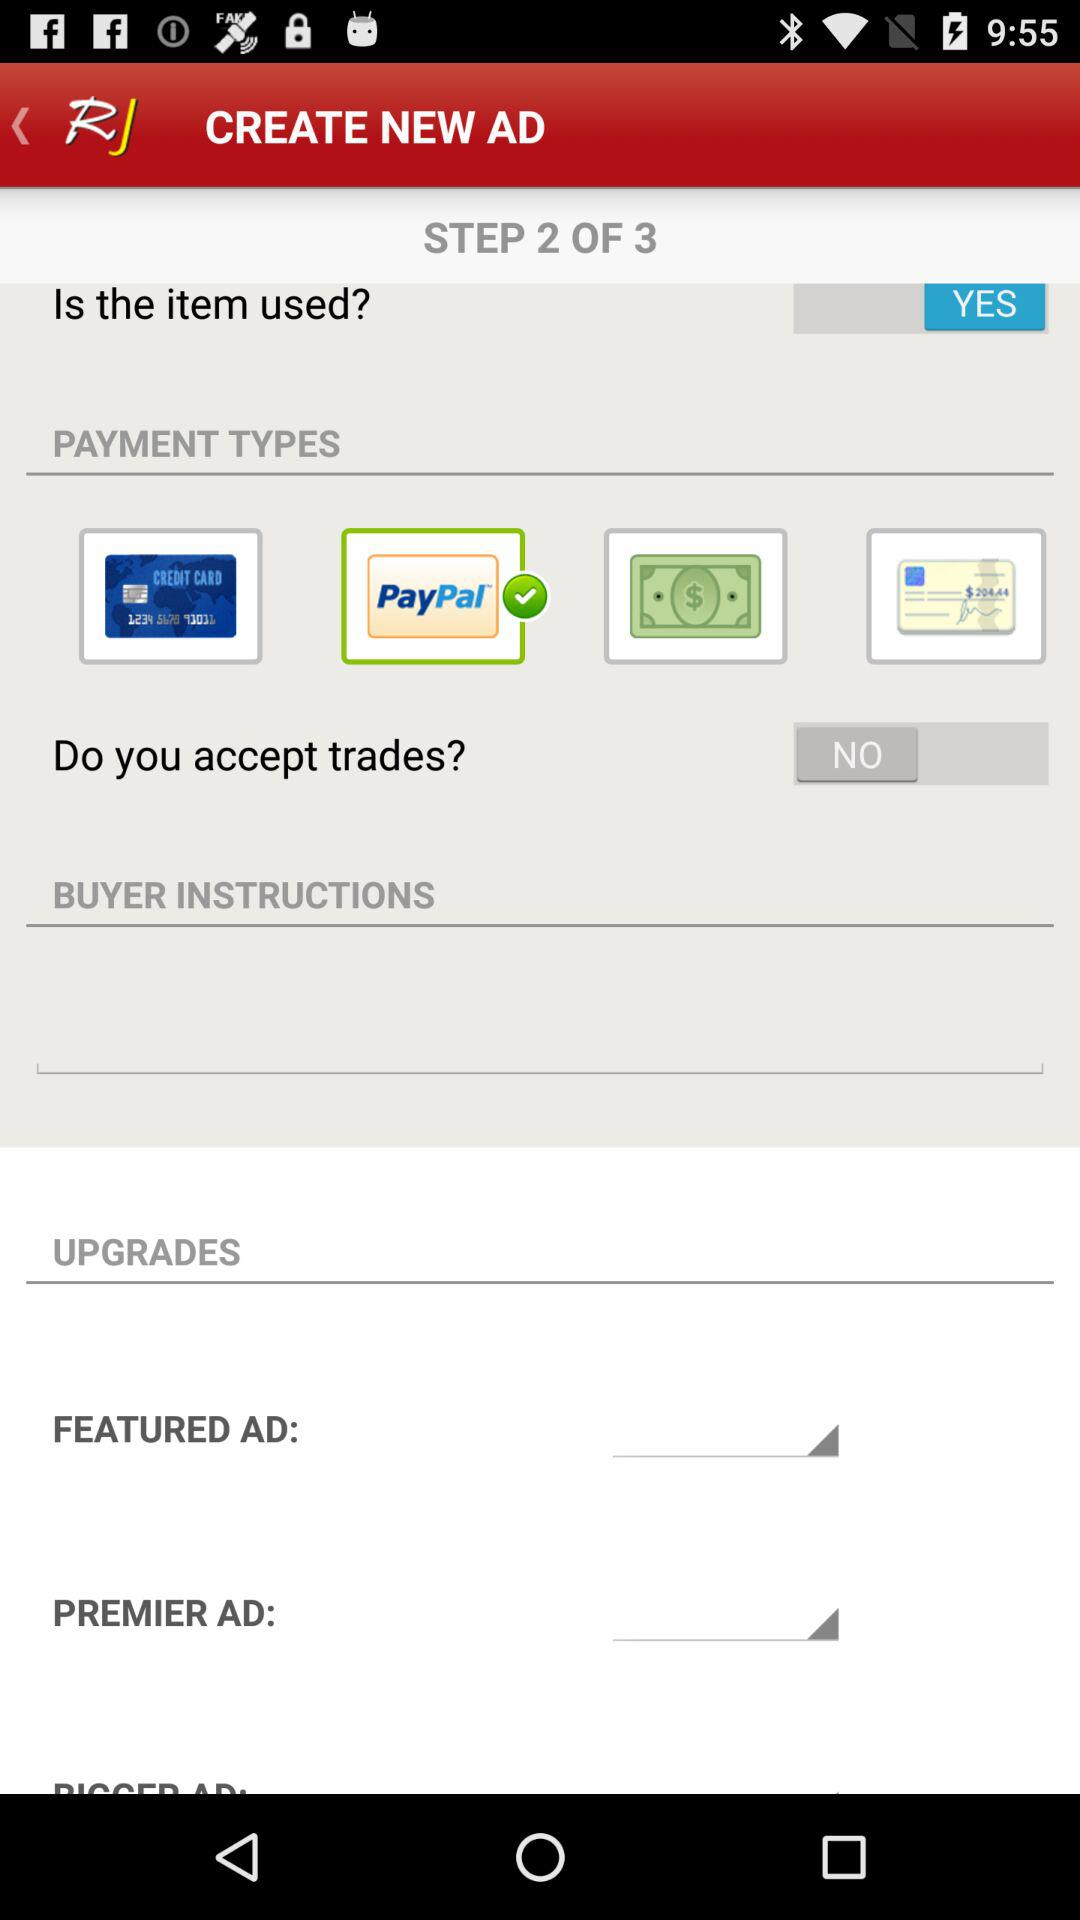What is the status of "Is the item used"? The status of "Is the item used" is "YES". 